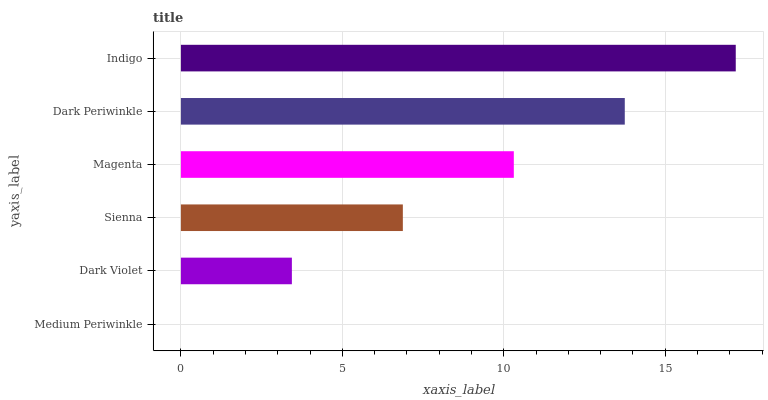Is Medium Periwinkle the minimum?
Answer yes or no. Yes. Is Indigo the maximum?
Answer yes or no. Yes. Is Dark Violet the minimum?
Answer yes or no. No. Is Dark Violet the maximum?
Answer yes or no. No. Is Dark Violet greater than Medium Periwinkle?
Answer yes or no. Yes. Is Medium Periwinkle less than Dark Violet?
Answer yes or no. Yes. Is Medium Periwinkle greater than Dark Violet?
Answer yes or no. No. Is Dark Violet less than Medium Periwinkle?
Answer yes or no. No. Is Magenta the high median?
Answer yes or no. Yes. Is Sienna the low median?
Answer yes or no. Yes. Is Dark Periwinkle the high median?
Answer yes or no. No. Is Magenta the low median?
Answer yes or no. No. 